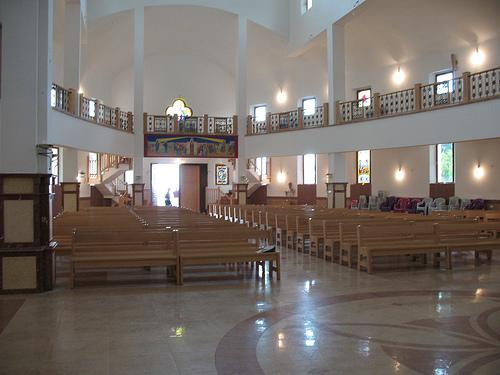Question: what color are the benches?
Choices:
A. White.
B. Black.
C. Gray.
D. The benches are brown.
Answer with the letter. Answer: D Question: what is in the picture?
Choices:
A. A lawn is in the picture.
B. A church is in the picture.
C. The sky is in the picture.
D. Your mom is in the picture.
Answer with the letter. Answer: B 